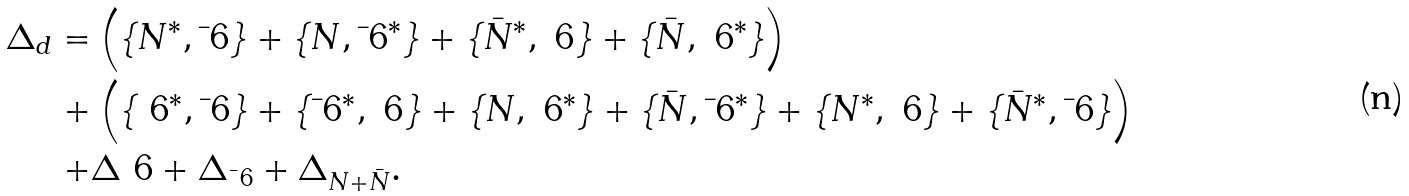Convert formula to latex. <formula><loc_0><loc_0><loc_500><loc_500>\Delta _ { d } = & \left ( \{ N ^ { * } , \bar { \ } 6 \} + \{ N , \bar { \ } 6 ^ { * } \} + \{ \bar { N } ^ { * } , \ 6 \} + \{ \bar { N } , \ 6 ^ { * } \} \right ) \\ + & \left ( \{ \ 6 ^ { * } , \bar { \ } 6 \} + \{ \bar { \ } 6 ^ { * } , \ 6 \} + \{ N , \ 6 ^ { * } \} + \{ \bar { N } , \bar { \ } 6 ^ { * } \} + \{ N ^ { * } , \ 6 \} + \{ \bar { N } ^ { * } , \bar { \ } 6 \} \right ) \\ + & \Delta _ { \ } 6 + \Delta _ { \bar { \ } 6 } + \Delta _ { N + \bar { N } } .</formula> 